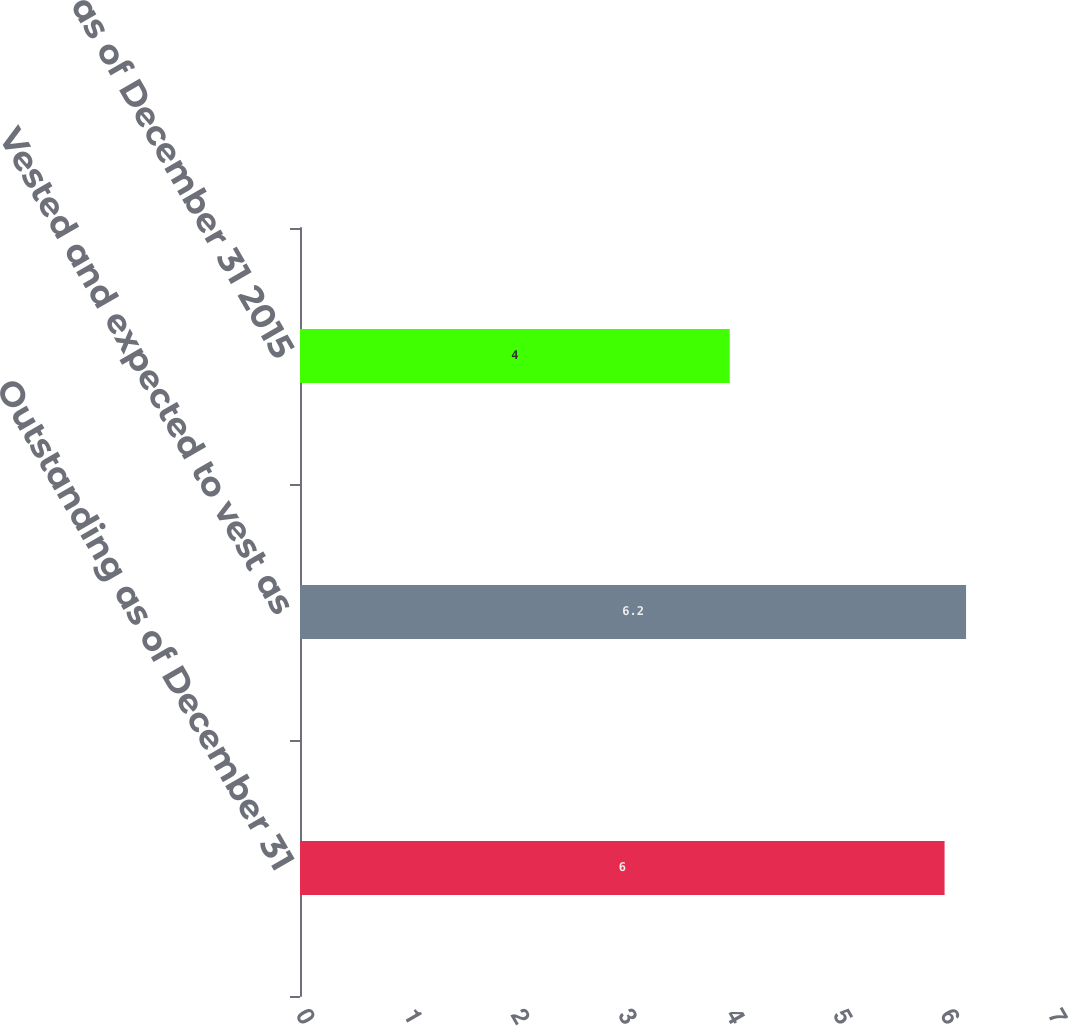<chart> <loc_0><loc_0><loc_500><loc_500><bar_chart><fcel>Outstanding as of December 31<fcel>Vested and expected to vest as<fcel>Vested as of December 31 2015<nl><fcel>6<fcel>6.2<fcel>4<nl></chart> 